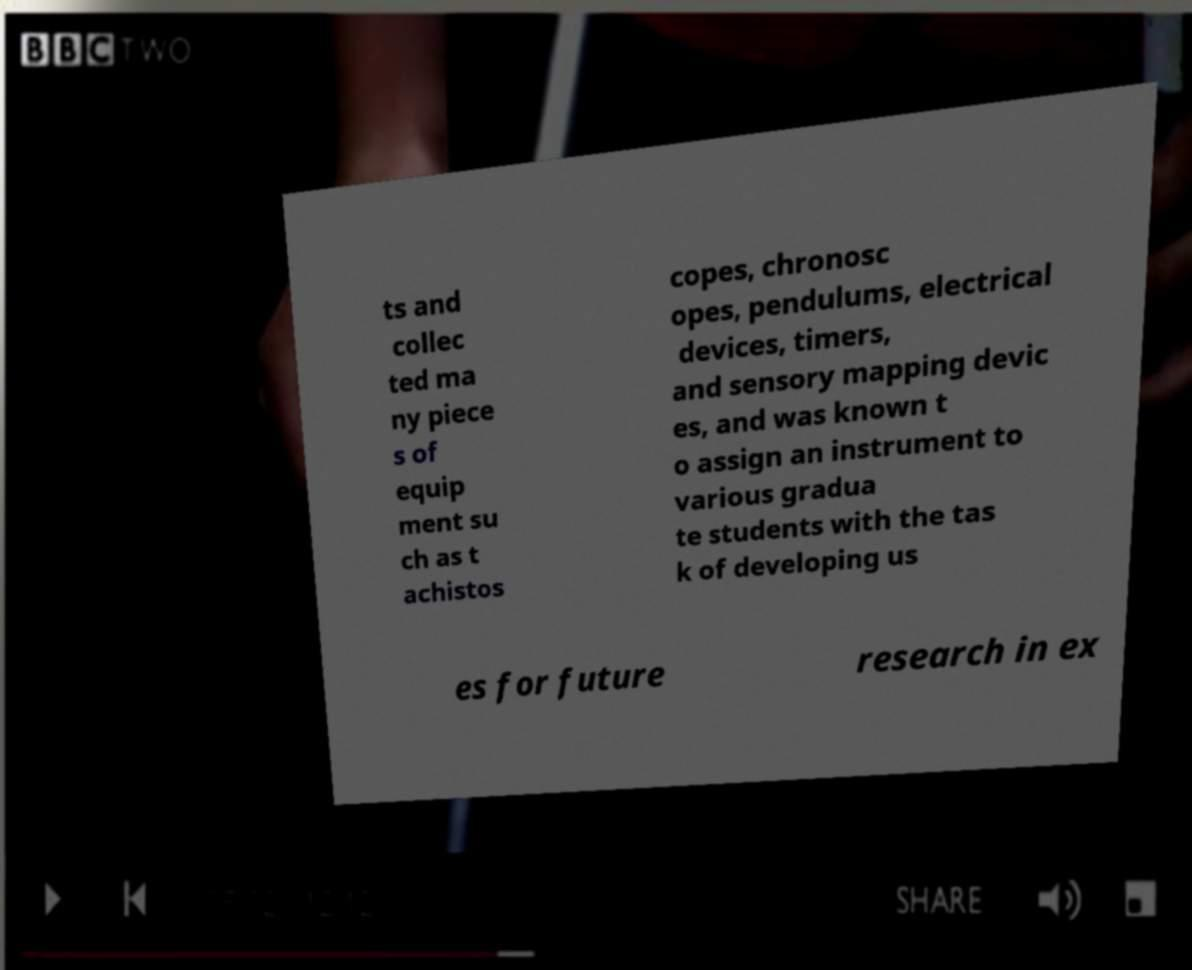Could you assist in decoding the text presented in this image and type it out clearly? ts and collec ted ma ny piece s of equip ment su ch as t achistos copes, chronosc opes, pendulums, electrical devices, timers, and sensory mapping devic es, and was known t o assign an instrument to various gradua te students with the tas k of developing us es for future research in ex 